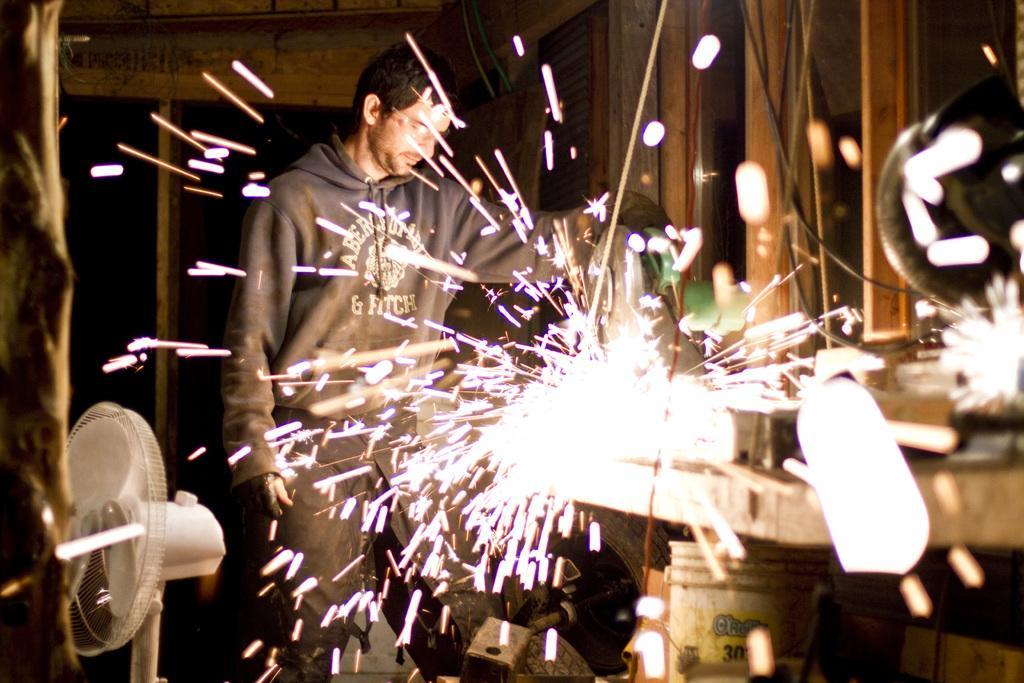Could you give a brief overview of what you see in this image? In this picture we can see a man wearing a jacket, spectacle and standing, windows, bucket, fan and in the background it is dark. 